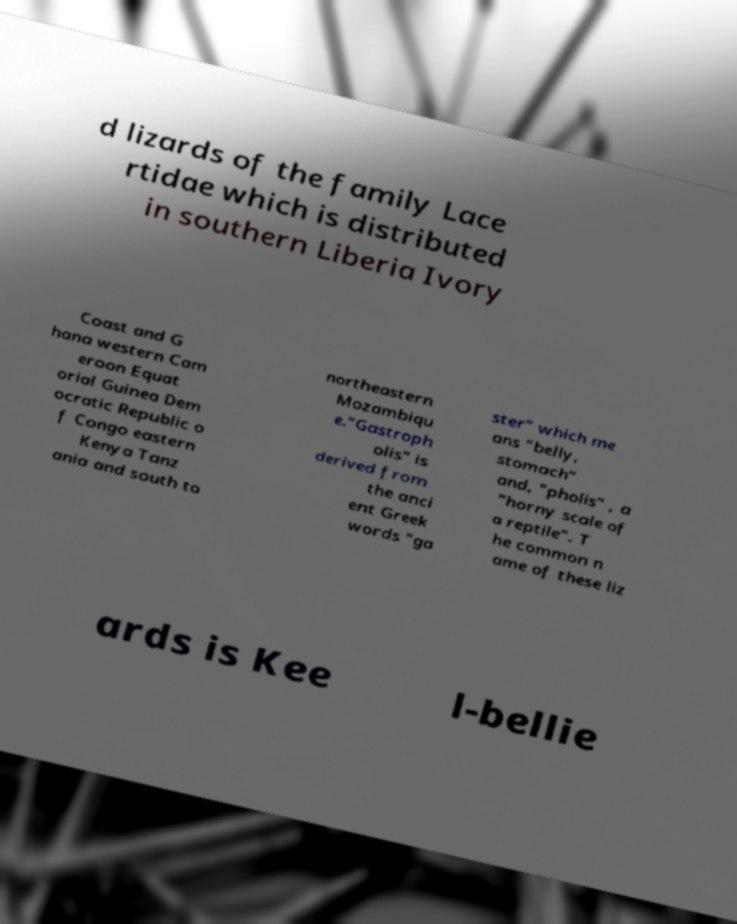Please identify and transcribe the text found in this image. d lizards of the family Lace rtidae which is distributed in southern Liberia Ivory Coast and G hana western Cam eroon Equat orial Guinea Dem ocratic Republic o f Congo eastern Kenya Tanz ania and south to northeastern Mozambiqu e."Gastroph olis" is derived from the anci ent Greek words "ga ster" which me ans "belly, stomach" and, "pholis" , a "horny scale of a reptile". T he common n ame of these liz ards is Kee l-bellie 